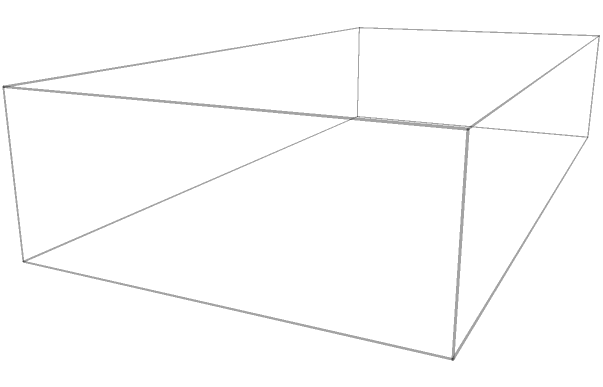As a tech entrepreneur developing a new line of high-capacity power banks, you need to optimize the packaging of cylindrical batteries. Your rectangular power bank measures 10cm x 5cm x 2cm. If each cylindrical battery has a diameter of 1.8cm and a height of 2cm, what is the maximum number of batteries that can be efficiently packed into the power bank using a hexagonal close-packing arrangement? How does this compare to a simple grid arrangement, and what percentage increase in capacity does it provide? Let's approach this step-by-step:

1) Simple grid arrangement:
   - In length: $\lfloor 10 / 1.8 \rfloor = 5$ batteries
   - In width: $\lfloor 5 / 1.8 \rfloor = 2$ batteries
   - Total: $5 \times 2 = 10$ batteries

2) Hexagonal close-packing:
   - In hexagonal packing, each battery is surrounded by 6 others.
   - The center-to-center distance between batteries is the diameter: 1.8cm
   - In the length (10cm):
     $\frac{10}{1.8} \approx 5.56$ batteries
   - In the width (5cm):
     In hexagonal packing, the vertical spacing is $\frac{\sqrt{3}}{2}$ times the diameter.
     $\frac{5}{1.8 \times \frac{\sqrt{3}}{2}} \approx 3.21$ batteries

3) Calculating the total for hexagonal packing:
   - We can fit 5 full columns and 3 rows
   - Odd columns have 3 batteries, even columns have 2
   - Total: $3 \times 3 + 2 \times 2 = 13$ batteries

4) Percentage increase:
   $\frac{13 - 10}{10} \times 100\% = 30\%$ increase in capacity

The hexagonal close-packing allows for 3 more batteries than the simple grid arrangement, providing a 30% increase in capacity.
Answer: 13 batteries; 30% increase over simple grid packing 